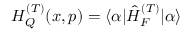<formula> <loc_0><loc_0><loc_500><loc_500>H _ { Q } ^ { ( T ) } ( x , p ) = \langle \alpha | \hat { H } _ { F } ^ { ( T ) } | \alpha \rangle</formula> 